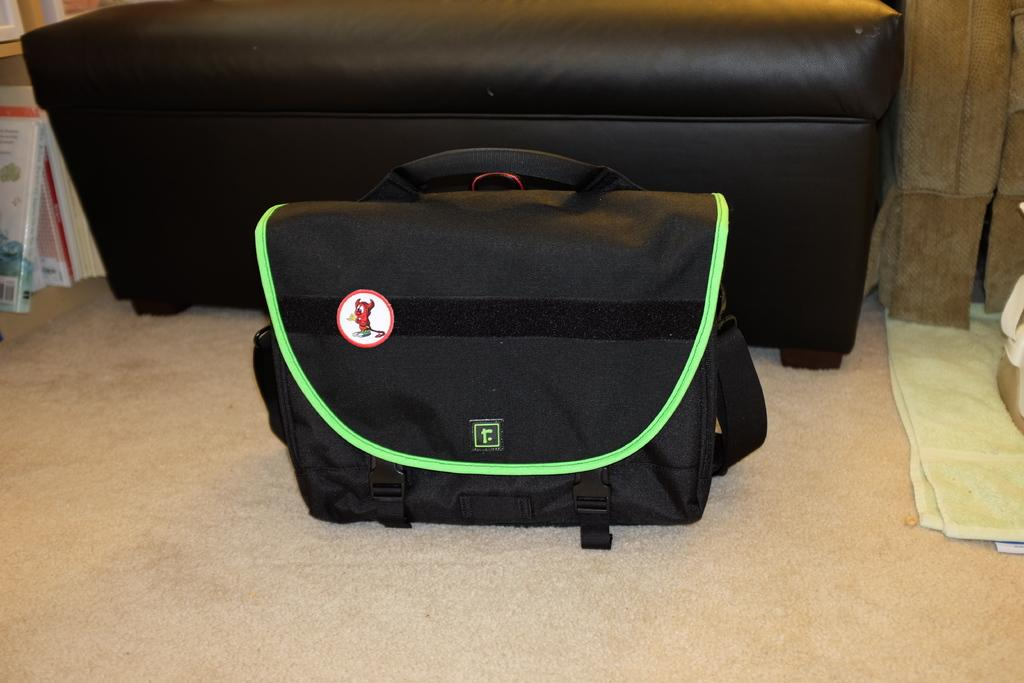What is on the floor in the image? There is a bag on the floor in the image. What type of furniture is in the image? There is a sofa in the image. What items can be seen besides the bag and sofa? There are books in the image. What is the flavor of the bag in the image? Bags do not have flavors; they are not edible items. The question is not relevant to the image. 